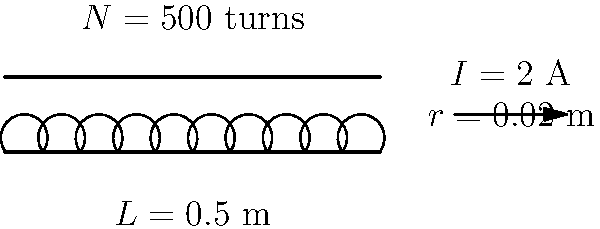A solenoid with 500 turns is 0.5 m long and has a radius of 0.02 m. If a current of 2 A flows through the wire, calculate the magnetic flux through the solenoid. Assume the magnetic field inside the solenoid is uniform and use the permeability of free space $\mu_0 = 4\pi \times 10^{-7}$ T⋅m/A. To solve this problem, we'll follow these steps:

1) First, we need to calculate the magnetic field strength (B) inside the solenoid using the formula:

   $$B = \mu_0 \frac{NI}{L}$$

   where $\mu_0$ is the permeability of free space, $N$ is the number of turns, $I$ is the current, and $L$ is the length of the solenoid.

2) Substituting the given values:

   $$B = (4\pi \times 10^{-7}) \frac{500 \times 2}{0.5} = 2.51 \times 10^{-3}$$ T

3) Now, we need to calculate the area of the solenoid's cross-section:

   $$A = \pi r^2 = \pi (0.02)^2 = 1.26 \times 10^{-3}$$ m²

4) The magnetic flux $\Phi$ is given by the product of the magnetic field and the area:

   $$\Phi = BA$$

5) Substituting our calculated values:

   $$\Phi = (2.51 \times 10^{-3})(1.26 \times 10^{-3}) = 3.16 \times 10^{-6}$$ Wb

Therefore, the magnetic flux through the solenoid is $3.16 \times 10^{-6}$ Wb.
Answer: $3.16 \times 10^{-6}$ Wb 